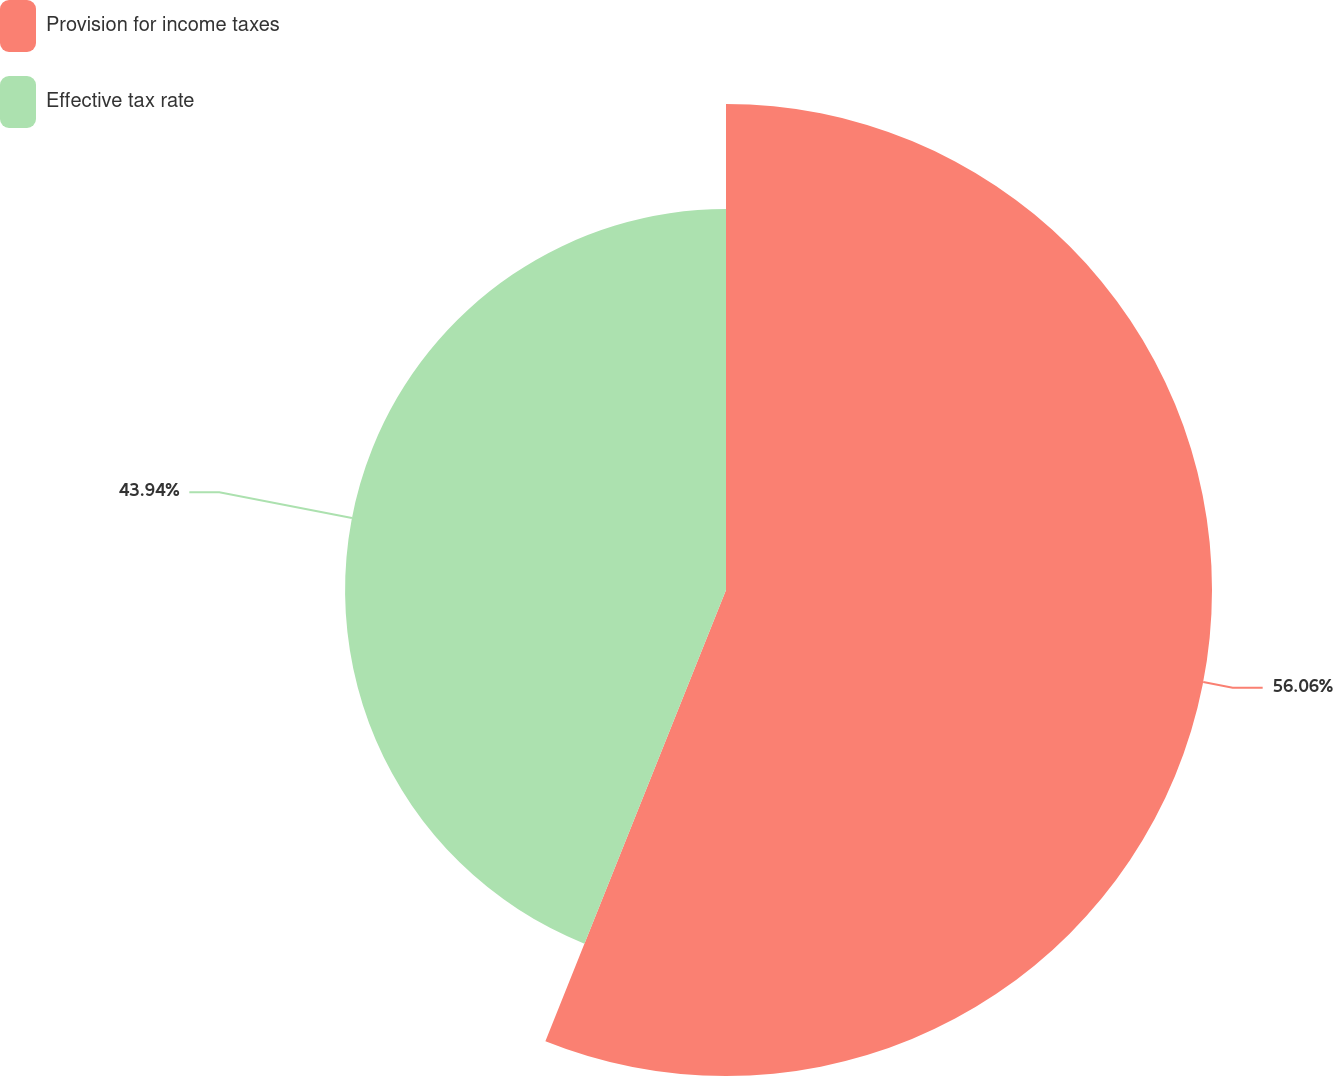Convert chart. <chart><loc_0><loc_0><loc_500><loc_500><pie_chart><fcel>Provision for income taxes<fcel>Effective tax rate<nl><fcel>56.06%<fcel>43.94%<nl></chart> 